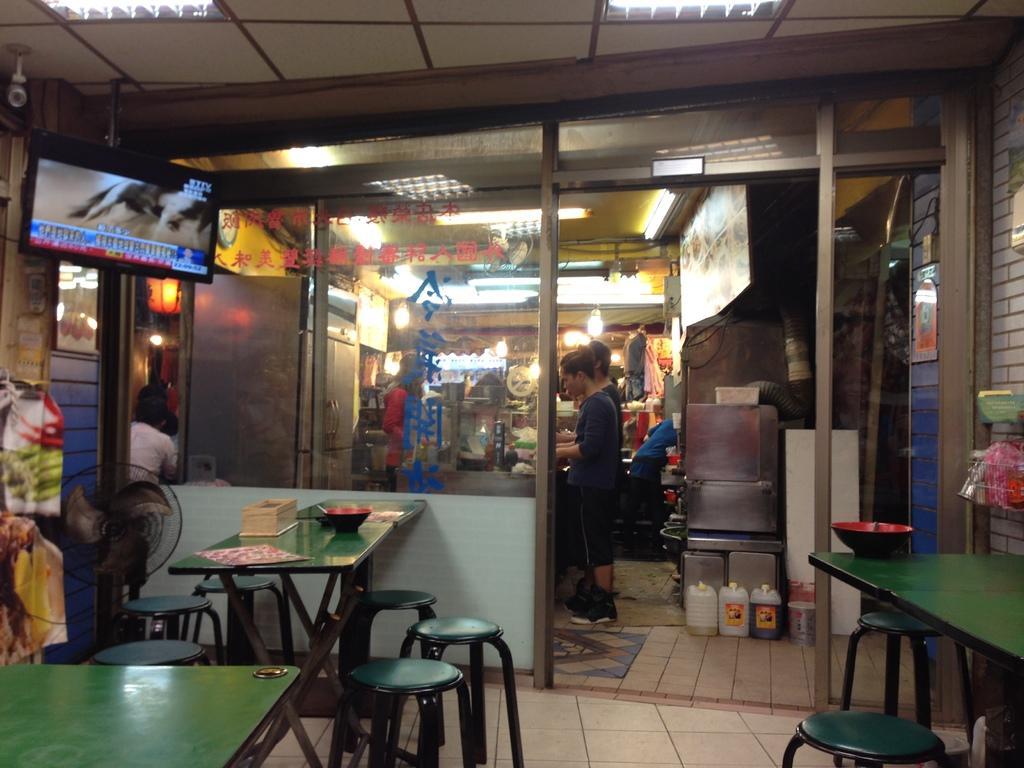How would you summarize this image in a sentence or two? In this picture I can see the tables and stools in front and I see few things on the tables. I can also see a table fan on the left side of this image. On the top left of this image I see a TV. In the background I see a store and I see few persons and I see the lights and in the middle of this picture I see few cans on the path. On the top of this image I see few more lights. 